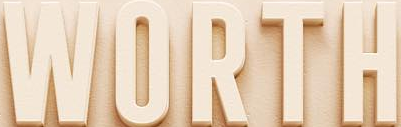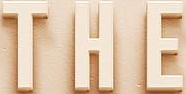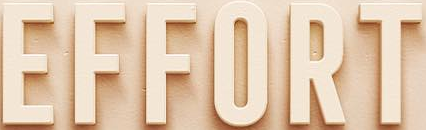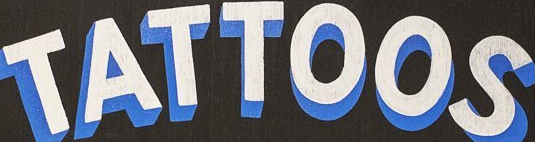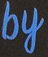What words are shown in these images in order, separated by a semicolon? WORTH; THE; EFFORT; TATTOOS; by 